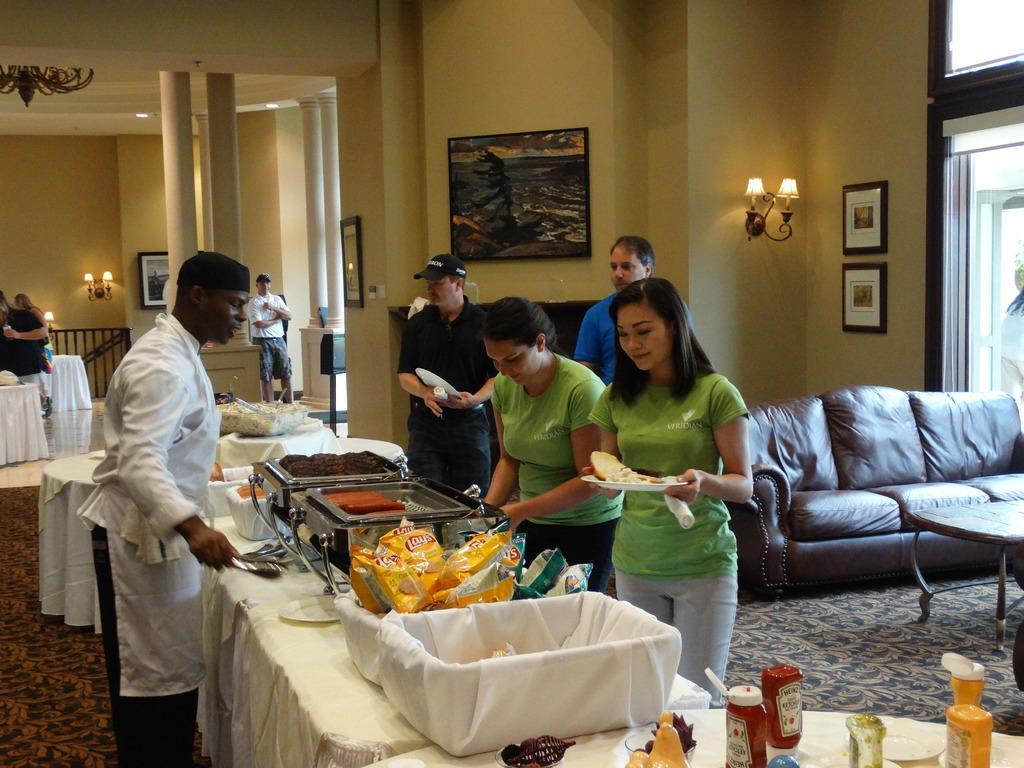In one or two sentences, can you explain what this image depicts? This picture describes about group of people. In the middle of the image we can see some food items on the table, and also we can see sofa, light, wall painting, photo frames on the wall. 